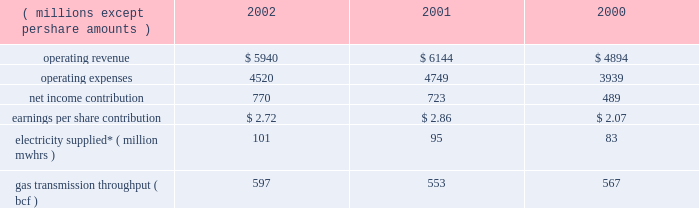Other taxes decreased in 2001 because its utility operations in virginia became subject to state income taxes in lieu of gross receipts taxes effective january 2001 .
In addition , dominion recognized higher effective rates for foreign earnings and higher pretax income in relation to non-conventional fuel tax credits realized .
Dominion energy 2002 2001 2000 ( millions , except per share amounts ) .
* amounts presented are for electricity supplied by utility and merchant generation operations .
Operating results 2014 2002 dominion energy contributed $ 2.72 per diluted share on net income of $ 770 million for 2002 , a net income increase of $ 47 million and an earnings per share decrease of $ 0.14 over 2001 .
Net income for 2002 reflected lower operating revenue ( $ 204 million ) , operating expenses ( $ 229 million ) and other income ( $ 27 million ) .
Interest expense and income taxes , which are discussed on a consolidated basis , decreased $ 50 million over 2001 .
The earnings per share decrease reflected share dilution .
Regulated electric sales revenue increased $ 179 million .
Favorable weather conditions , reflecting increased cooling and heating degree-days , as well as customer growth , are estimated to have contributed $ 133 million and $ 41 million , respectively .
Fuel rate recoveries increased approximately $ 65 million for 2002 .
These recoveries are generally offset by increases in elec- tric fuel expense and do not materially affect income .
Partially offsetting these increases was a net decrease of $ 60 million due to other factors not separately measurable , such as the impact of economic conditions on customer usage , as well as variations in seasonal rate premiums and discounts .
Nonregulated electric sales revenue increased $ 9 million .
Sales revenue from dominion 2019s merchant generation fleet decreased $ 21 million , reflecting a $ 201 million decline due to lower prices partially offset by sales from assets acquired and constructed in 2002 and the inclusion of millstone operations for all of 2002 .
Revenue from the wholesale marketing of utility generation decreased $ 74 million .
Due to the higher demand of utility service territory customers during 2002 , less production from utility plant generation was available for profitable sale in the wholesale market .
Revenue from retail energy sales increased $ 71 million , reflecting primarily customer growth over the prior year .
Net revenue from dominion 2019s electric trading activities increased $ 33 million , reflecting the effect of favorable price changes on unsettled contracts and higher trading margins .
Nonregulated gas sales revenue decreased $ 351 million .
The decrease included a $ 239 million decrease in sales by dominion 2019s field services and retail energy marketing opera- tions , reflecting to a large extent declining prices .
Revenue associated with gas trading operations , net of related cost of sales , decreased $ 112 million .
The decrease included $ 70 mil- lion of realized and unrealized losses on the economic hedges of natural gas production by the dominion exploration & pro- duction segment .
As described below under selected information 2014 energy trading activities , sales of natural gas by the dominion exploration & production segment at market prices offset these financial losses , resulting in a range of prices contemplated by dominion 2019s overall risk management strategy .
The remaining $ 42 million decrease was due to unfavorable price changes on unsettled contracts and lower overall trading margins .
Those losses were partially offset by contributions from higher trading volumes in gas and oil markets .
Gas transportation and storage revenue decreased $ 44 million , primarily reflecting lower rates .
Electric fuel and energy purchases expense increased $ 94 million which included an increase of $ 66 million associated with dominion 2019s energy marketing operations that are not sub- ject to cost-based rate regulation and an increase of $ 28 million associated with utility operations .
Substantially all of the increase associated with non-regulated energy marketing opera- tions related to higher volumes purchased during the year .
For utility operations , energy costs increased $ 66 million for pur- chases subject to rate recovery , partially offset by a $ 38 million decrease in fuel expenses associated with lower wholesale mar- keting of utility plant generation .
Purchased gas expense decreased $ 245 million associated with dominion 2019s field services and retail energy marketing oper- ations .
This decrease reflected approximately $ 162 million asso- ciated with declining prices and $ 83 million associated with lower purchased volumes .
Liquids , pipeline capacity and other purchases decreased $ 64 million , primarily reflecting comparably lower levels of rate recoveries of certain costs of transmission operations in the cur- rent year period .
The difference between actual expenses and amounts recovered in the period are deferred pending future rate adjustments .
Other operations and maintenance expense decreased $ 14 million , primarily reflecting an $ 18 million decrease in outage costs due to fewer generation unit outages in the current year .
Depreciation expense decreased $ 11 million , reflecting decreases in depreciation associated with changes in the esti- mated useful lives of certain electric generation property , par- tially offset by increased depreciation associated with state line and millstone operations .
Other income decreased $ 27 million , including a $ 14 mil- lion decrease in net realized investment gains in the millstone 37d o m i n i o n 2019 0 2 a n n u a l r e p o r t .
What is the growth rate in operating revenue from 2000 to 2001? 
Computations: ((6144 - 4894) / 4894)
Answer: 0.25541. 